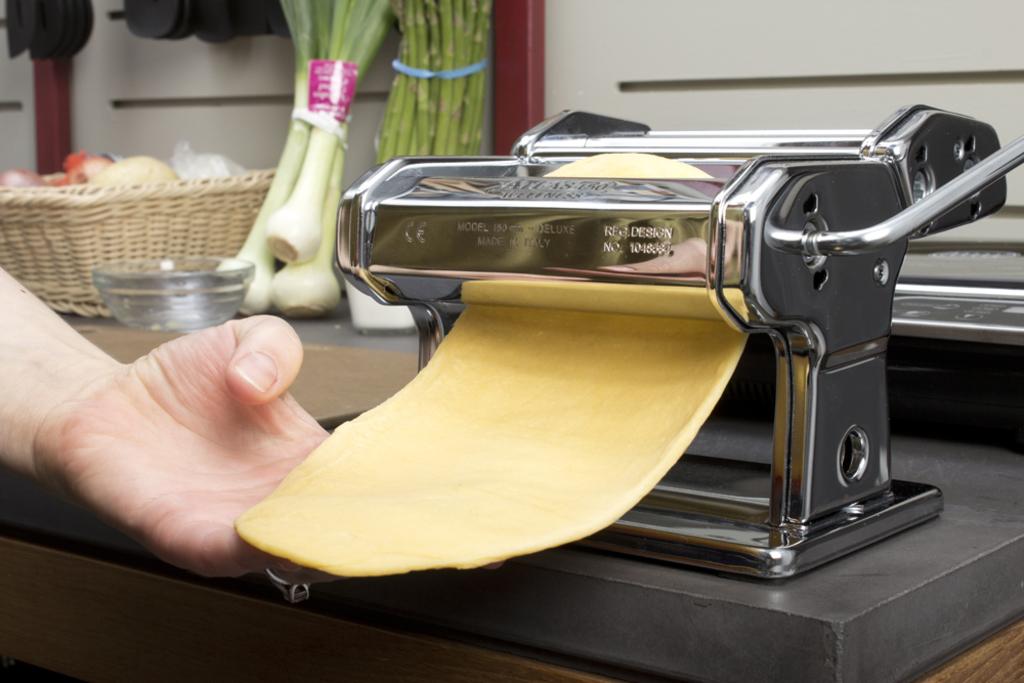Where was the machine made?
Provide a succinct answer. Italy. 